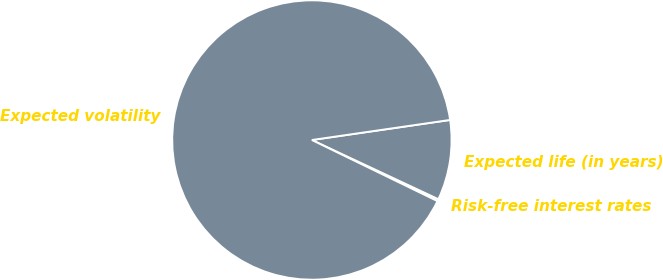Convert chart to OTSL. <chart><loc_0><loc_0><loc_500><loc_500><pie_chart><fcel>Risk-free interest rates<fcel>Expected life (in years)<fcel>Expected volatility<nl><fcel>0.24%<fcel>9.26%<fcel>90.5%<nl></chart> 